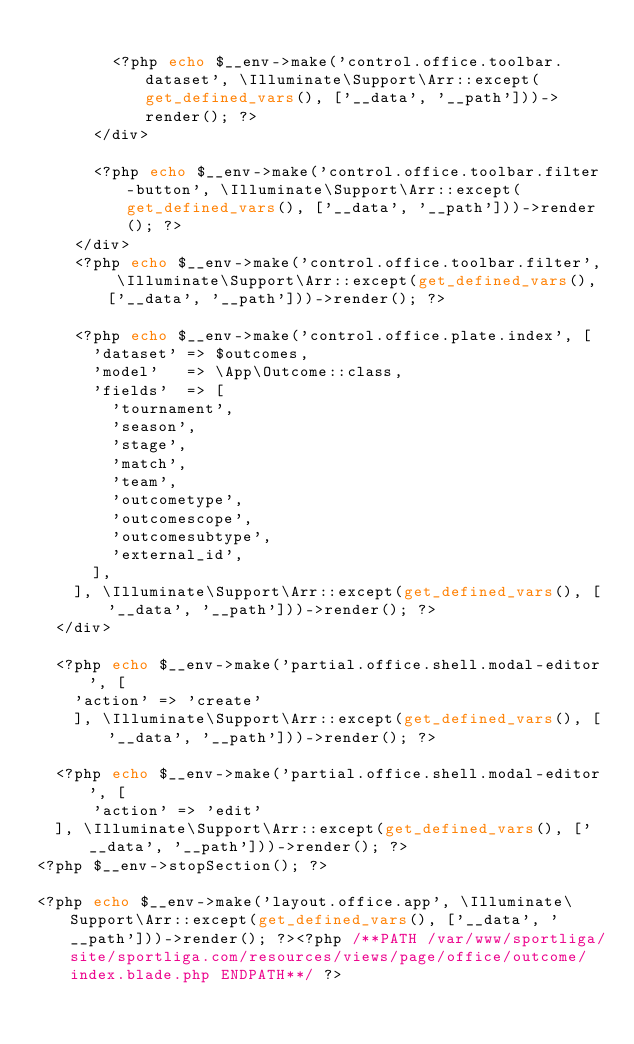Convert code to text. <code><loc_0><loc_0><loc_500><loc_500><_PHP_>
				<?php echo $__env->make('control.office.toolbar.dataset', \Illuminate\Support\Arr::except(get_defined_vars(), ['__data', '__path']))->render(); ?>
			</div>

			<?php echo $__env->make('control.office.toolbar.filter-button', \Illuminate\Support\Arr::except(get_defined_vars(), ['__data', '__path']))->render(); ?>
		</div>
		<?php echo $__env->make('control.office.toolbar.filter', \Illuminate\Support\Arr::except(get_defined_vars(), ['__data', '__path']))->render(); ?>

		<?php echo $__env->make('control.office.plate.index', [
			'dataset'	=> $outcomes,
			'model'		=> \App\Outcome::class,
			'fields'	=> [
				'tournament',
				'season',
				'stage',
				'match',
				'team',
				'outcometype',
				'outcomescope',
				'outcomesubtype',
				'external_id',
			],
		], \Illuminate\Support\Arr::except(get_defined_vars(), ['__data', '__path']))->render(); ?>
	</div>

	<?php echo $__env->make('partial.office.shell.modal-editor', [
		'action' => 'create'
    ], \Illuminate\Support\Arr::except(get_defined_vars(), ['__data', '__path']))->render(); ?>

	<?php echo $__env->make('partial.office.shell.modal-editor', [
    	'action' => 'edit'
	], \Illuminate\Support\Arr::except(get_defined_vars(), ['__data', '__path']))->render(); ?>
<?php $__env->stopSection(); ?>

<?php echo $__env->make('layout.office.app', \Illuminate\Support\Arr::except(get_defined_vars(), ['__data', '__path']))->render(); ?><?php /**PATH /var/www/sportliga/site/sportliga.com/resources/views/page/office/outcome/index.blade.php ENDPATH**/ ?></code> 